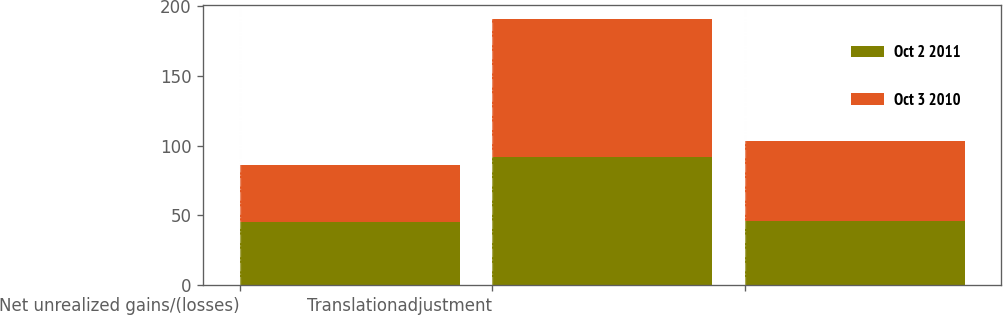<chart> <loc_0><loc_0><loc_500><loc_500><stacked_bar_chart><ecel><fcel>Net unrealized gains/(losses)<fcel>Translationadjustment<fcel>Unnamed: 3<nl><fcel>Oct 2 2011<fcel>45.3<fcel>92.1<fcel>46.3<nl><fcel>Oct 3 2010<fcel>40.5<fcel>98.6<fcel>57.2<nl></chart> 